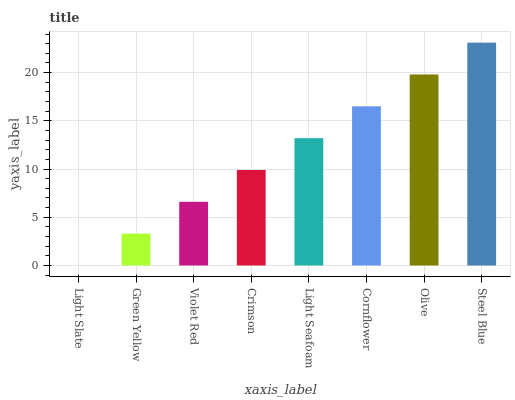Is Green Yellow the minimum?
Answer yes or no. No. Is Green Yellow the maximum?
Answer yes or no. No. Is Green Yellow greater than Light Slate?
Answer yes or no. Yes. Is Light Slate less than Green Yellow?
Answer yes or no. Yes. Is Light Slate greater than Green Yellow?
Answer yes or no. No. Is Green Yellow less than Light Slate?
Answer yes or no. No. Is Light Seafoam the high median?
Answer yes or no. Yes. Is Crimson the low median?
Answer yes or no. Yes. Is Olive the high median?
Answer yes or no. No. Is Olive the low median?
Answer yes or no. No. 